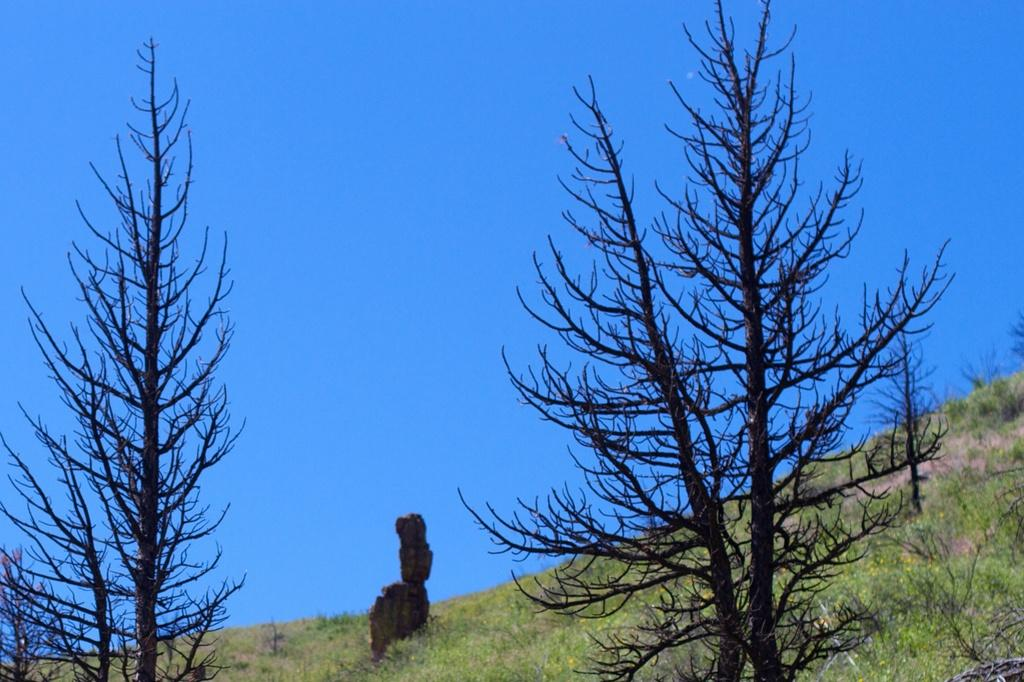What type of vegetation can be seen in the image? There are trees in the image. What else can be found on the ground in the image? There are rocks in the image. What is the surface of the ground like in the image? The ground is visible in the image and is covered with grass. What color is the bubble floating in the sky in the image? There is no bubble present in the image. How does the moon affect the lighting in the image? The image does not depict the moon or any moonlight. 